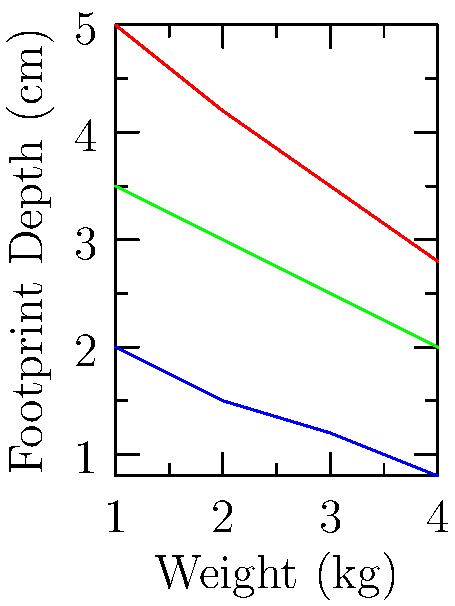Based on the graph showing footprint depth variations in different soil types under increasing weight, which soil type demonstrates the highest resistance to footprint impression, and what forensic implications does this have? To answer this question, we need to analyze the graph and understand the relationship between soil types and footprint depth:

1. Observe the three lines representing different soil types: clay (red), sand (blue), and loam (green).

2. Compare the slopes of the lines:
   - Clay has the steepest slope, indicating rapid increase in depth with weight.
   - Sand has the flattest slope, showing the least change in depth with weight.
   - Loam is intermediate between clay and sand.

3. Interpret the slopes:
   - A flatter slope indicates higher resistance to footprint impression.
   - The flattest slope (sand) represents the highest resistance.

4. Forensic implications:
   - Sand will preserve less detailed footprints due to its high resistance.
   - Shallower impressions in sand may be more easily disturbed or eroded.
   - Clay and loam will likely provide more detailed and persistent footprint evidence.
   - The depth and quality of footprint impressions can help estimate the weight of the suspect.
   - Understanding soil type is crucial for proper evidence collection and interpretation.
Answer: Sand; less detailed and persistent footprint evidence. 